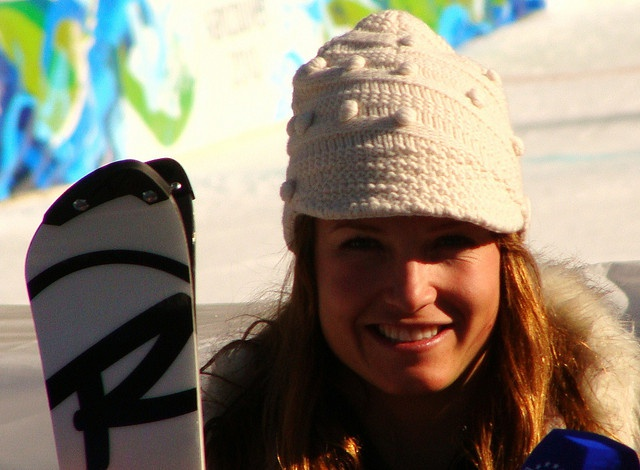Describe the objects in this image and their specific colors. I can see people in beige, black, maroon, and tan tones and snowboard in beige, black, and gray tones in this image. 